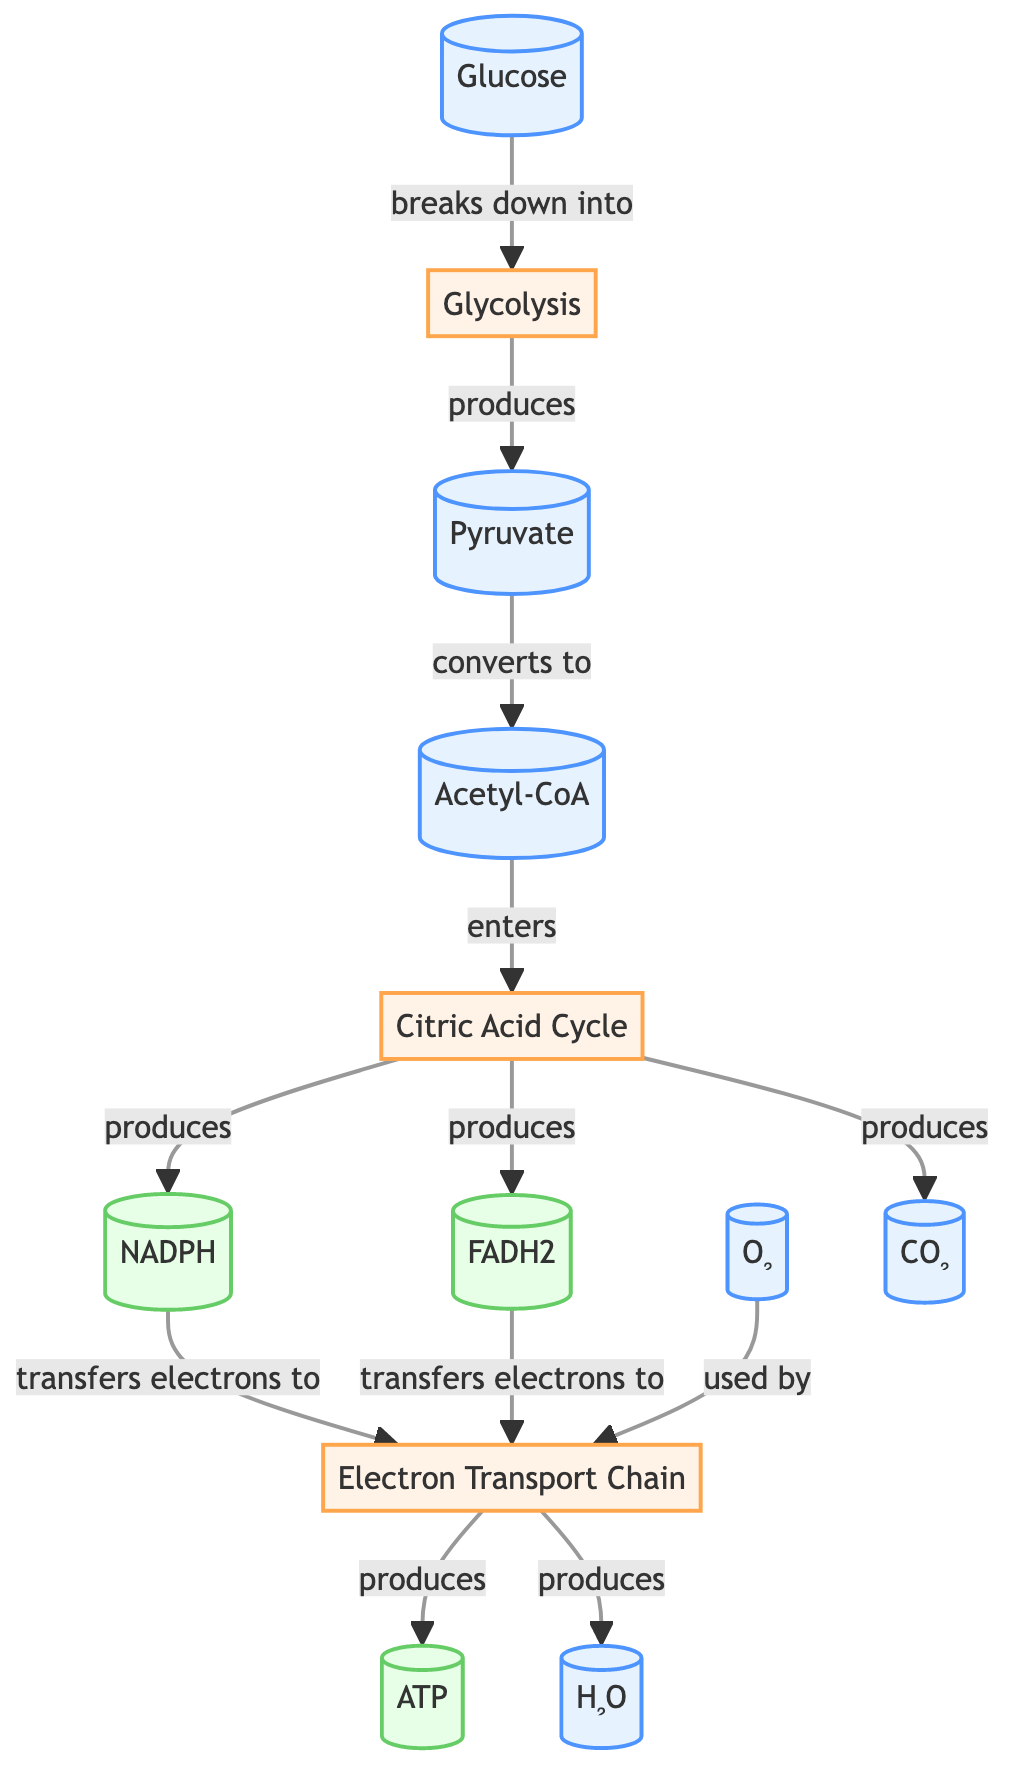What is the first molecule used in the pathway? The diagram shows that glucose is the starting molecule for the metabolic pathway. It is explicitly labeled as "Glucose" at the beginning of the diagram.
Answer: Glucose How many energy products are produced in the pathway? By examining the diagram, we see three energy products listed: ATP, NADPH, and FADH2. Counting these, there are a total of three energy products produced.
Answer: 3 What molecule does pyruvate convert to? The diagram indicates that pyruvate is converted to acetyl-CoA, as shown by the arrow pointing from pyruvate to acetyl-CoA with the label "converts to."
Answer: Acetyl-CoA Which process produces carbon dioxide? In the diagram, the "Citric Acid Cycle" is the process that produces carbon dioxide, as indicated by the arrow leading from the Citric Acid Cycle to CO2 with the label "produces."
Answer: Citric Acid Cycle What is used by the electron transport chain? The diagram states that the electron transport chain uses oxygen (O2), as indicated by the arrow pointing towards the electron transport chain with the label "used by."
Answer: O₂ What are the two coenzymes that transfer electrons to the electron transport chain? The diagram shows that NADPH and FADH2 are the two coenzymes that transfer electrons to the electron transport chain, each pointing to "et" from their respective processes.
Answer: NADPH, FADH2 Which step in the pathway follows glycolysis? Following glycolysis, the diagram indicates that the next step involves the production of pyruvate, as shown by the arrow leading from glycolysis to pyruvate.
Answer: Pyruvate How many processes are represented in the diagram? The diagram displays three main processes: Glycolysis, Citric Acid Cycle, and Electron Transport Chain. Counting these processes gives a total of three.
Answer: 3 Which molecule is produced alongside ATP in the electron transport chain? According to the diagram, water (H2O) is produced alongside ATP in the electron transport chain, as indicated by the parallel arrows leading from "etc" to both ATP and H2O.
Answer: H₂O 